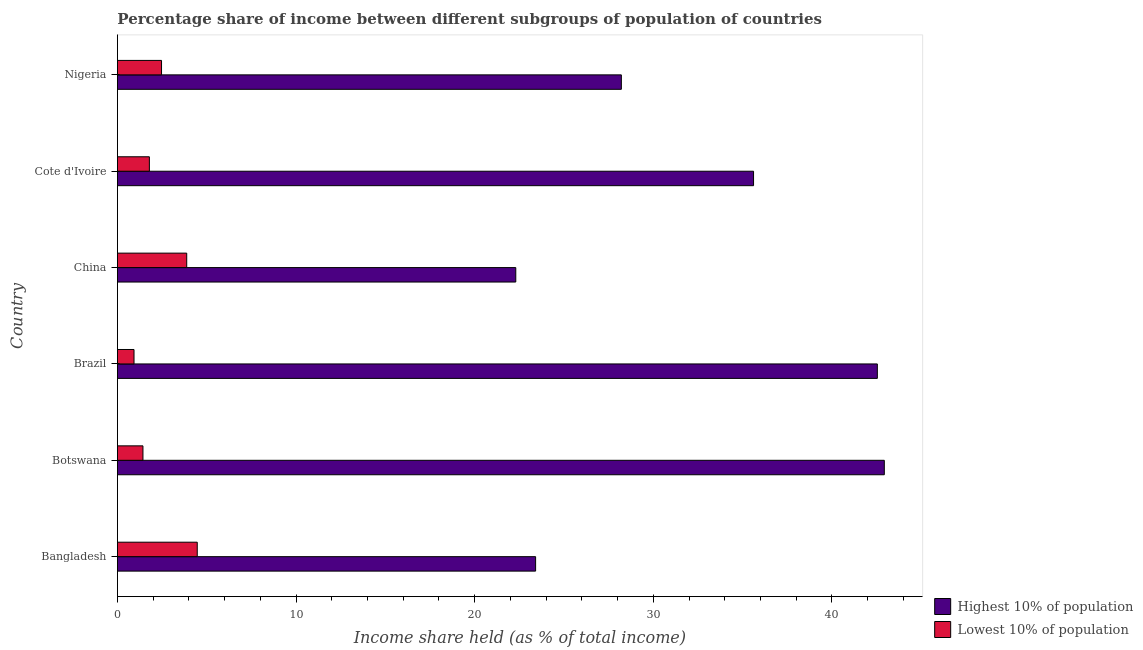How many groups of bars are there?
Offer a very short reply. 6. Are the number of bars on each tick of the Y-axis equal?
Your answer should be very brief. Yes. How many bars are there on the 3rd tick from the top?
Your answer should be very brief. 2. In how many cases, is the number of bars for a given country not equal to the number of legend labels?
Give a very brief answer. 0. What is the income share held by highest 10% of the population in Botswana?
Offer a terse response. 42.93. Across all countries, what is the maximum income share held by highest 10% of the population?
Give a very brief answer. 42.93. Across all countries, what is the minimum income share held by highest 10% of the population?
Provide a short and direct response. 22.3. What is the total income share held by lowest 10% of the population in the graph?
Make the answer very short. 14.97. What is the difference between the income share held by highest 10% of the population in Brazil and that in Nigeria?
Offer a very short reply. 14.33. What is the difference between the income share held by highest 10% of the population in Bangladesh and the income share held by lowest 10% of the population in Botswana?
Keep it short and to the point. 21.98. What is the average income share held by lowest 10% of the population per country?
Your answer should be compact. 2.5. What is the difference between the income share held by highest 10% of the population and income share held by lowest 10% of the population in Brazil?
Your answer should be very brief. 41.61. What is the difference between the highest and the second highest income share held by highest 10% of the population?
Your response must be concise. 0.39. What is the difference between the highest and the lowest income share held by lowest 10% of the population?
Give a very brief answer. 3.54. Is the sum of the income share held by lowest 10% of the population in Bangladesh and China greater than the maximum income share held by highest 10% of the population across all countries?
Provide a succinct answer. No. What does the 1st bar from the top in Nigeria represents?
Provide a short and direct response. Lowest 10% of population. What does the 1st bar from the bottom in Cote d'Ivoire represents?
Give a very brief answer. Highest 10% of population. How many bars are there?
Your answer should be compact. 12. Are all the bars in the graph horizontal?
Ensure brevity in your answer.  Yes. How many countries are there in the graph?
Ensure brevity in your answer.  6. Are the values on the major ticks of X-axis written in scientific E-notation?
Offer a very short reply. No. Does the graph contain any zero values?
Your answer should be very brief. No. Where does the legend appear in the graph?
Provide a short and direct response. Bottom right. How many legend labels are there?
Ensure brevity in your answer.  2. What is the title of the graph?
Offer a terse response. Percentage share of income between different subgroups of population of countries. Does "Under-5(male)" appear as one of the legend labels in the graph?
Your response must be concise. No. What is the label or title of the X-axis?
Give a very brief answer. Income share held (as % of total income). What is the label or title of the Y-axis?
Offer a terse response. Country. What is the Income share held (as % of total income) in Highest 10% of population in Bangladesh?
Give a very brief answer. 23.41. What is the Income share held (as % of total income) of Lowest 10% of population in Bangladesh?
Offer a very short reply. 4.47. What is the Income share held (as % of total income) in Highest 10% of population in Botswana?
Make the answer very short. 42.93. What is the Income share held (as % of total income) of Lowest 10% of population in Botswana?
Offer a terse response. 1.43. What is the Income share held (as % of total income) in Highest 10% of population in Brazil?
Provide a succinct answer. 42.54. What is the Income share held (as % of total income) in Highest 10% of population in China?
Provide a short and direct response. 22.3. What is the Income share held (as % of total income) of Lowest 10% of population in China?
Your answer should be very brief. 3.88. What is the Income share held (as % of total income) of Highest 10% of population in Cote d'Ivoire?
Offer a very short reply. 35.61. What is the Income share held (as % of total income) in Lowest 10% of population in Cote d'Ivoire?
Give a very brief answer. 1.79. What is the Income share held (as % of total income) in Highest 10% of population in Nigeria?
Make the answer very short. 28.21. What is the Income share held (as % of total income) in Lowest 10% of population in Nigeria?
Your answer should be very brief. 2.47. Across all countries, what is the maximum Income share held (as % of total income) in Highest 10% of population?
Offer a very short reply. 42.93. Across all countries, what is the maximum Income share held (as % of total income) in Lowest 10% of population?
Ensure brevity in your answer.  4.47. Across all countries, what is the minimum Income share held (as % of total income) in Highest 10% of population?
Give a very brief answer. 22.3. What is the total Income share held (as % of total income) in Highest 10% of population in the graph?
Keep it short and to the point. 195. What is the total Income share held (as % of total income) in Lowest 10% of population in the graph?
Give a very brief answer. 14.97. What is the difference between the Income share held (as % of total income) in Highest 10% of population in Bangladesh and that in Botswana?
Keep it short and to the point. -19.52. What is the difference between the Income share held (as % of total income) in Lowest 10% of population in Bangladesh and that in Botswana?
Keep it short and to the point. 3.04. What is the difference between the Income share held (as % of total income) of Highest 10% of population in Bangladesh and that in Brazil?
Offer a very short reply. -19.13. What is the difference between the Income share held (as % of total income) of Lowest 10% of population in Bangladesh and that in Brazil?
Offer a very short reply. 3.54. What is the difference between the Income share held (as % of total income) of Highest 10% of population in Bangladesh and that in China?
Provide a short and direct response. 1.11. What is the difference between the Income share held (as % of total income) in Lowest 10% of population in Bangladesh and that in China?
Your answer should be very brief. 0.59. What is the difference between the Income share held (as % of total income) of Highest 10% of population in Bangladesh and that in Cote d'Ivoire?
Provide a short and direct response. -12.2. What is the difference between the Income share held (as % of total income) in Lowest 10% of population in Bangladesh and that in Cote d'Ivoire?
Keep it short and to the point. 2.68. What is the difference between the Income share held (as % of total income) in Lowest 10% of population in Bangladesh and that in Nigeria?
Your response must be concise. 2. What is the difference between the Income share held (as % of total income) in Highest 10% of population in Botswana and that in Brazil?
Make the answer very short. 0.39. What is the difference between the Income share held (as % of total income) in Lowest 10% of population in Botswana and that in Brazil?
Keep it short and to the point. 0.5. What is the difference between the Income share held (as % of total income) in Highest 10% of population in Botswana and that in China?
Provide a succinct answer. 20.63. What is the difference between the Income share held (as % of total income) of Lowest 10% of population in Botswana and that in China?
Ensure brevity in your answer.  -2.45. What is the difference between the Income share held (as % of total income) of Highest 10% of population in Botswana and that in Cote d'Ivoire?
Your answer should be very brief. 7.32. What is the difference between the Income share held (as % of total income) in Lowest 10% of population in Botswana and that in Cote d'Ivoire?
Offer a very short reply. -0.36. What is the difference between the Income share held (as % of total income) of Highest 10% of population in Botswana and that in Nigeria?
Provide a short and direct response. 14.72. What is the difference between the Income share held (as % of total income) of Lowest 10% of population in Botswana and that in Nigeria?
Your answer should be compact. -1.04. What is the difference between the Income share held (as % of total income) in Highest 10% of population in Brazil and that in China?
Your response must be concise. 20.24. What is the difference between the Income share held (as % of total income) of Lowest 10% of population in Brazil and that in China?
Offer a very short reply. -2.95. What is the difference between the Income share held (as % of total income) of Highest 10% of population in Brazil and that in Cote d'Ivoire?
Your response must be concise. 6.93. What is the difference between the Income share held (as % of total income) in Lowest 10% of population in Brazil and that in Cote d'Ivoire?
Make the answer very short. -0.86. What is the difference between the Income share held (as % of total income) in Highest 10% of population in Brazil and that in Nigeria?
Offer a very short reply. 14.33. What is the difference between the Income share held (as % of total income) of Lowest 10% of population in Brazil and that in Nigeria?
Give a very brief answer. -1.54. What is the difference between the Income share held (as % of total income) of Highest 10% of population in China and that in Cote d'Ivoire?
Provide a succinct answer. -13.31. What is the difference between the Income share held (as % of total income) of Lowest 10% of population in China and that in Cote d'Ivoire?
Provide a succinct answer. 2.09. What is the difference between the Income share held (as % of total income) of Highest 10% of population in China and that in Nigeria?
Offer a very short reply. -5.91. What is the difference between the Income share held (as % of total income) in Lowest 10% of population in China and that in Nigeria?
Provide a short and direct response. 1.41. What is the difference between the Income share held (as % of total income) of Highest 10% of population in Cote d'Ivoire and that in Nigeria?
Your answer should be very brief. 7.4. What is the difference between the Income share held (as % of total income) in Lowest 10% of population in Cote d'Ivoire and that in Nigeria?
Ensure brevity in your answer.  -0.68. What is the difference between the Income share held (as % of total income) of Highest 10% of population in Bangladesh and the Income share held (as % of total income) of Lowest 10% of population in Botswana?
Offer a terse response. 21.98. What is the difference between the Income share held (as % of total income) of Highest 10% of population in Bangladesh and the Income share held (as % of total income) of Lowest 10% of population in Brazil?
Give a very brief answer. 22.48. What is the difference between the Income share held (as % of total income) of Highest 10% of population in Bangladesh and the Income share held (as % of total income) of Lowest 10% of population in China?
Keep it short and to the point. 19.53. What is the difference between the Income share held (as % of total income) of Highest 10% of population in Bangladesh and the Income share held (as % of total income) of Lowest 10% of population in Cote d'Ivoire?
Provide a succinct answer. 21.62. What is the difference between the Income share held (as % of total income) of Highest 10% of population in Bangladesh and the Income share held (as % of total income) of Lowest 10% of population in Nigeria?
Offer a very short reply. 20.94. What is the difference between the Income share held (as % of total income) of Highest 10% of population in Botswana and the Income share held (as % of total income) of Lowest 10% of population in China?
Provide a succinct answer. 39.05. What is the difference between the Income share held (as % of total income) of Highest 10% of population in Botswana and the Income share held (as % of total income) of Lowest 10% of population in Cote d'Ivoire?
Ensure brevity in your answer.  41.14. What is the difference between the Income share held (as % of total income) in Highest 10% of population in Botswana and the Income share held (as % of total income) in Lowest 10% of population in Nigeria?
Offer a very short reply. 40.46. What is the difference between the Income share held (as % of total income) of Highest 10% of population in Brazil and the Income share held (as % of total income) of Lowest 10% of population in China?
Your answer should be very brief. 38.66. What is the difference between the Income share held (as % of total income) in Highest 10% of population in Brazil and the Income share held (as % of total income) in Lowest 10% of population in Cote d'Ivoire?
Offer a terse response. 40.75. What is the difference between the Income share held (as % of total income) of Highest 10% of population in Brazil and the Income share held (as % of total income) of Lowest 10% of population in Nigeria?
Provide a short and direct response. 40.07. What is the difference between the Income share held (as % of total income) of Highest 10% of population in China and the Income share held (as % of total income) of Lowest 10% of population in Cote d'Ivoire?
Your answer should be compact. 20.51. What is the difference between the Income share held (as % of total income) of Highest 10% of population in China and the Income share held (as % of total income) of Lowest 10% of population in Nigeria?
Provide a short and direct response. 19.83. What is the difference between the Income share held (as % of total income) of Highest 10% of population in Cote d'Ivoire and the Income share held (as % of total income) of Lowest 10% of population in Nigeria?
Offer a very short reply. 33.14. What is the average Income share held (as % of total income) of Highest 10% of population per country?
Provide a succinct answer. 32.5. What is the average Income share held (as % of total income) in Lowest 10% of population per country?
Offer a terse response. 2.5. What is the difference between the Income share held (as % of total income) in Highest 10% of population and Income share held (as % of total income) in Lowest 10% of population in Bangladesh?
Provide a short and direct response. 18.94. What is the difference between the Income share held (as % of total income) of Highest 10% of population and Income share held (as % of total income) of Lowest 10% of population in Botswana?
Keep it short and to the point. 41.5. What is the difference between the Income share held (as % of total income) in Highest 10% of population and Income share held (as % of total income) in Lowest 10% of population in Brazil?
Your answer should be very brief. 41.61. What is the difference between the Income share held (as % of total income) in Highest 10% of population and Income share held (as % of total income) in Lowest 10% of population in China?
Provide a short and direct response. 18.42. What is the difference between the Income share held (as % of total income) of Highest 10% of population and Income share held (as % of total income) of Lowest 10% of population in Cote d'Ivoire?
Give a very brief answer. 33.82. What is the difference between the Income share held (as % of total income) of Highest 10% of population and Income share held (as % of total income) of Lowest 10% of population in Nigeria?
Provide a succinct answer. 25.74. What is the ratio of the Income share held (as % of total income) in Highest 10% of population in Bangladesh to that in Botswana?
Make the answer very short. 0.55. What is the ratio of the Income share held (as % of total income) in Lowest 10% of population in Bangladesh to that in Botswana?
Your response must be concise. 3.13. What is the ratio of the Income share held (as % of total income) of Highest 10% of population in Bangladesh to that in Brazil?
Provide a succinct answer. 0.55. What is the ratio of the Income share held (as % of total income) in Lowest 10% of population in Bangladesh to that in Brazil?
Offer a very short reply. 4.81. What is the ratio of the Income share held (as % of total income) of Highest 10% of population in Bangladesh to that in China?
Provide a succinct answer. 1.05. What is the ratio of the Income share held (as % of total income) of Lowest 10% of population in Bangladesh to that in China?
Your answer should be very brief. 1.15. What is the ratio of the Income share held (as % of total income) of Highest 10% of population in Bangladesh to that in Cote d'Ivoire?
Provide a succinct answer. 0.66. What is the ratio of the Income share held (as % of total income) of Lowest 10% of population in Bangladesh to that in Cote d'Ivoire?
Ensure brevity in your answer.  2.5. What is the ratio of the Income share held (as % of total income) in Highest 10% of population in Bangladesh to that in Nigeria?
Your answer should be very brief. 0.83. What is the ratio of the Income share held (as % of total income) of Lowest 10% of population in Bangladesh to that in Nigeria?
Ensure brevity in your answer.  1.81. What is the ratio of the Income share held (as % of total income) in Highest 10% of population in Botswana to that in Brazil?
Give a very brief answer. 1.01. What is the ratio of the Income share held (as % of total income) in Lowest 10% of population in Botswana to that in Brazil?
Your answer should be compact. 1.54. What is the ratio of the Income share held (as % of total income) in Highest 10% of population in Botswana to that in China?
Provide a short and direct response. 1.93. What is the ratio of the Income share held (as % of total income) of Lowest 10% of population in Botswana to that in China?
Provide a short and direct response. 0.37. What is the ratio of the Income share held (as % of total income) in Highest 10% of population in Botswana to that in Cote d'Ivoire?
Provide a short and direct response. 1.21. What is the ratio of the Income share held (as % of total income) of Lowest 10% of population in Botswana to that in Cote d'Ivoire?
Offer a very short reply. 0.8. What is the ratio of the Income share held (as % of total income) of Highest 10% of population in Botswana to that in Nigeria?
Make the answer very short. 1.52. What is the ratio of the Income share held (as % of total income) of Lowest 10% of population in Botswana to that in Nigeria?
Provide a short and direct response. 0.58. What is the ratio of the Income share held (as % of total income) of Highest 10% of population in Brazil to that in China?
Provide a short and direct response. 1.91. What is the ratio of the Income share held (as % of total income) of Lowest 10% of population in Brazil to that in China?
Provide a succinct answer. 0.24. What is the ratio of the Income share held (as % of total income) in Highest 10% of population in Brazil to that in Cote d'Ivoire?
Your response must be concise. 1.19. What is the ratio of the Income share held (as % of total income) in Lowest 10% of population in Brazil to that in Cote d'Ivoire?
Make the answer very short. 0.52. What is the ratio of the Income share held (as % of total income) of Highest 10% of population in Brazil to that in Nigeria?
Offer a very short reply. 1.51. What is the ratio of the Income share held (as % of total income) of Lowest 10% of population in Brazil to that in Nigeria?
Your answer should be very brief. 0.38. What is the ratio of the Income share held (as % of total income) in Highest 10% of population in China to that in Cote d'Ivoire?
Offer a very short reply. 0.63. What is the ratio of the Income share held (as % of total income) in Lowest 10% of population in China to that in Cote d'Ivoire?
Offer a very short reply. 2.17. What is the ratio of the Income share held (as % of total income) in Highest 10% of population in China to that in Nigeria?
Give a very brief answer. 0.79. What is the ratio of the Income share held (as % of total income) in Lowest 10% of population in China to that in Nigeria?
Offer a terse response. 1.57. What is the ratio of the Income share held (as % of total income) in Highest 10% of population in Cote d'Ivoire to that in Nigeria?
Offer a very short reply. 1.26. What is the ratio of the Income share held (as % of total income) of Lowest 10% of population in Cote d'Ivoire to that in Nigeria?
Your answer should be very brief. 0.72. What is the difference between the highest and the second highest Income share held (as % of total income) of Highest 10% of population?
Offer a terse response. 0.39. What is the difference between the highest and the second highest Income share held (as % of total income) of Lowest 10% of population?
Provide a succinct answer. 0.59. What is the difference between the highest and the lowest Income share held (as % of total income) of Highest 10% of population?
Provide a short and direct response. 20.63. What is the difference between the highest and the lowest Income share held (as % of total income) of Lowest 10% of population?
Provide a short and direct response. 3.54. 